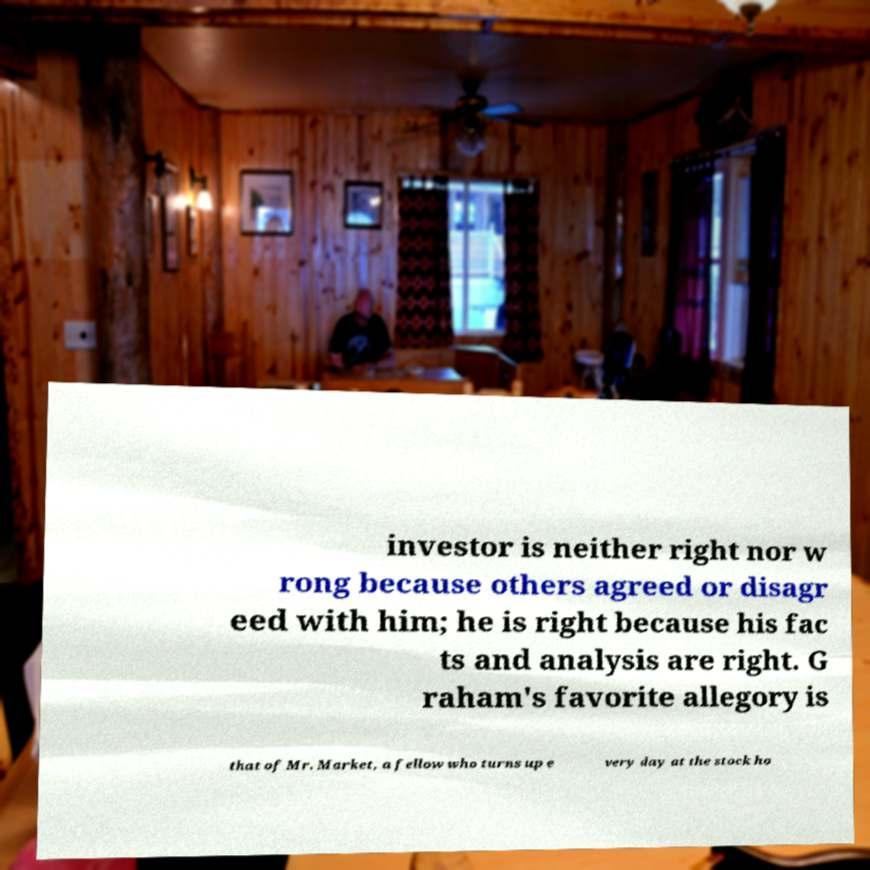For documentation purposes, I need the text within this image transcribed. Could you provide that? investor is neither right nor w rong because others agreed or disagr eed with him; he is right because his fac ts and analysis are right. G raham's favorite allegory is that of Mr. Market, a fellow who turns up e very day at the stock ho 